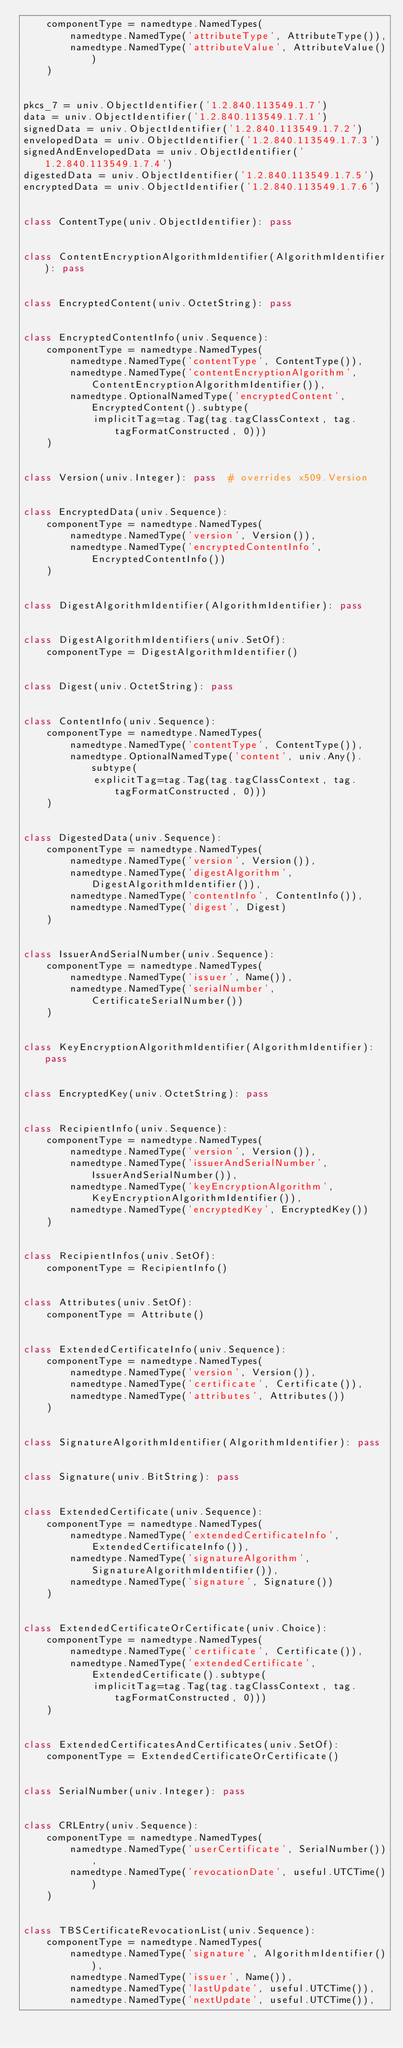<code> <loc_0><loc_0><loc_500><loc_500><_Python_>    componentType = namedtype.NamedTypes(
        namedtype.NamedType('attributeType', AttributeType()),
        namedtype.NamedType('attributeValue', AttributeValue())
    )


pkcs_7 = univ.ObjectIdentifier('1.2.840.113549.1.7')
data = univ.ObjectIdentifier('1.2.840.113549.1.7.1')
signedData = univ.ObjectIdentifier('1.2.840.113549.1.7.2')
envelopedData = univ.ObjectIdentifier('1.2.840.113549.1.7.3')
signedAndEnvelopedData = univ.ObjectIdentifier('1.2.840.113549.1.7.4')
digestedData = univ.ObjectIdentifier('1.2.840.113549.1.7.5')
encryptedData = univ.ObjectIdentifier('1.2.840.113549.1.7.6')


class ContentType(univ.ObjectIdentifier): pass


class ContentEncryptionAlgorithmIdentifier(AlgorithmIdentifier): pass


class EncryptedContent(univ.OctetString): pass


class EncryptedContentInfo(univ.Sequence):
    componentType = namedtype.NamedTypes(
        namedtype.NamedType('contentType', ContentType()),
        namedtype.NamedType('contentEncryptionAlgorithm', ContentEncryptionAlgorithmIdentifier()),
        namedtype.OptionalNamedType('encryptedContent', EncryptedContent().subtype(
            implicitTag=tag.Tag(tag.tagClassContext, tag.tagFormatConstructed, 0)))
    )


class Version(univ.Integer): pass  # overrides x509.Version


class EncryptedData(univ.Sequence):
    componentType = namedtype.NamedTypes(
        namedtype.NamedType('version', Version()),
        namedtype.NamedType('encryptedContentInfo', EncryptedContentInfo())
    )


class DigestAlgorithmIdentifier(AlgorithmIdentifier): pass


class DigestAlgorithmIdentifiers(univ.SetOf):
    componentType = DigestAlgorithmIdentifier()


class Digest(univ.OctetString): pass


class ContentInfo(univ.Sequence):
    componentType = namedtype.NamedTypes(
        namedtype.NamedType('contentType', ContentType()),
        namedtype.OptionalNamedType('content', univ.Any().subtype(
            explicitTag=tag.Tag(tag.tagClassContext, tag.tagFormatConstructed, 0)))
    )


class DigestedData(univ.Sequence):
    componentType = namedtype.NamedTypes(
        namedtype.NamedType('version', Version()),
        namedtype.NamedType('digestAlgorithm', DigestAlgorithmIdentifier()),
        namedtype.NamedType('contentInfo', ContentInfo()),
        namedtype.NamedType('digest', Digest)
    )


class IssuerAndSerialNumber(univ.Sequence):
    componentType = namedtype.NamedTypes(
        namedtype.NamedType('issuer', Name()),
        namedtype.NamedType('serialNumber', CertificateSerialNumber())
    )


class KeyEncryptionAlgorithmIdentifier(AlgorithmIdentifier): pass


class EncryptedKey(univ.OctetString): pass


class RecipientInfo(univ.Sequence):
    componentType = namedtype.NamedTypes(
        namedtype.NamedType('version', Version()),
        namedtype.NamedType('issuerAndSerialNumber', IssuerAndSerialNumber()),
        namedtype.NamedType('keyEncryptionAlgorithm', KeyEncryptionAlgorithmIdentifier()),
        namedtype.NamedType('encryptedKey', EncryptedKey())
    )


class RecipientInfos(univ.SetOf):
    componentType = RecipientInfo()


class Attributes(univ.SetOf):
    componentType = Attribute()


class ExtendedCertificateInfo(univ.Sequence):
    componentType = namedtype.NamedTypes(
        namedtype.NamedType('version', Version()),
        namedtype.NamedType('certificate', Certificate()),
        namedtype.NamedType('attributes', Attributes())
    )


class SignatureAlgorithmIdentifier(AlgorithmIdentifier): pass


class Signature(univ.BitString): pass


class ExtendedCertificate(univ.Sequence):
    componentType = namedtype.NamedTypes(
        namedtype.NamedType('extendedCertificateInfo', ExtendedCertificateInfo()),
        namedtype.NamedType('signatureAlgorithm', SignatureAlgorithmIdentifier()),
        namedtype.NamedType('signature', Signature())
    )


class ExtendedCertificateOrCertificate(univ.Choice):
    componentType = namedtype.NamedTypes(
        namedtype.NamedType('certificate', Certificate()),
        namedtype.NamedType('extendedCertificate', ExtendedCertificate().subtype(
            implicitTag=tag.Tag(tag.tagClassContext, tag.tagFormatConstructed, 0)))
    )


class ExtendedCertificatesAndCertificates(univ.SetOf):
    componentType = ExtendedCertificateOrCertificate()


class SerialNumber(univ.Integer): pass


class CRLEntry(univ.Sequence):
    componentType = namedtype.NamedTypes(
        namedtype.NamedType('userCertificate', SerialNumber()),
        namedtype.NamedType('revocationDate', useful.UTCTime())
    )


class TBSCertificateRevocationList(univ.Sequence):
    componentType = namedtype.NamedTypes(
        namedtype.NamedType('signature', AlgorithmIdentifier()),
        namedtype.NamedType('issuer', Name()),
        namedtype.NamedType('lastUpdate', useful.UTCTime()),
        namedtype.NamedType('nextUpdate', useful.UTCTime()),</code> 